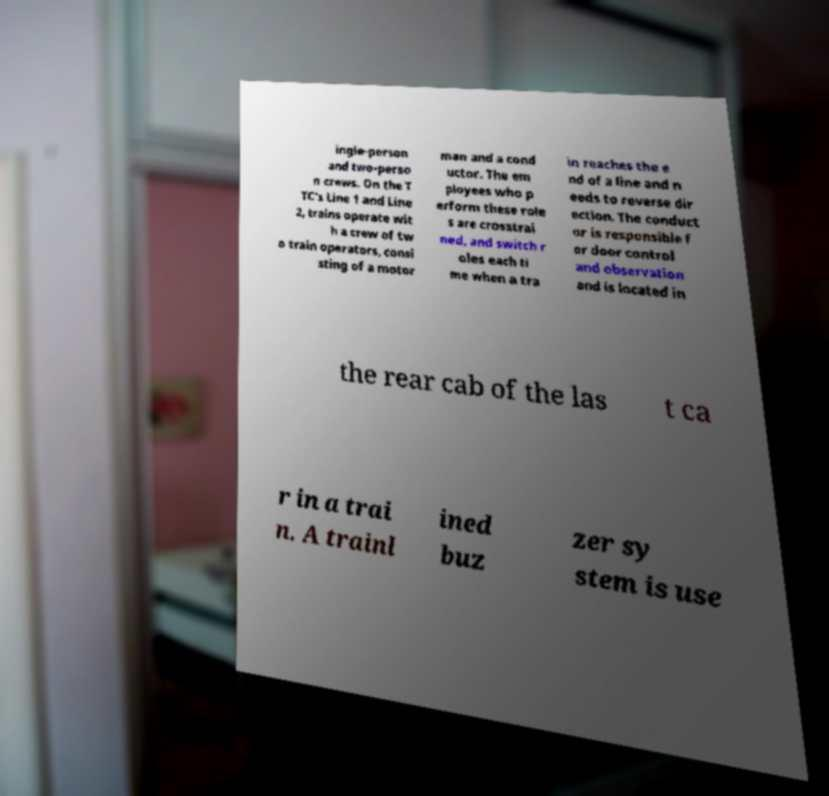Please identify and transcribe the text found in this image. ingle-person and two-perso n crews. On the T TC's Line 1 and Line 2, trains operate wit h a crew of tw o train operators, consi sting of a motor man and a cond uctor. The em ployees who p erform these role s are crosstrai ned, and switch r oles each ti me when a tra in reaches the e nd of a line and n eeds to reverse dir ection. The conduct or is responsible f or door control and observation and is located in the rear cab of the las t ca r in a trai n. A trainl ined buz zer sy stem is use 